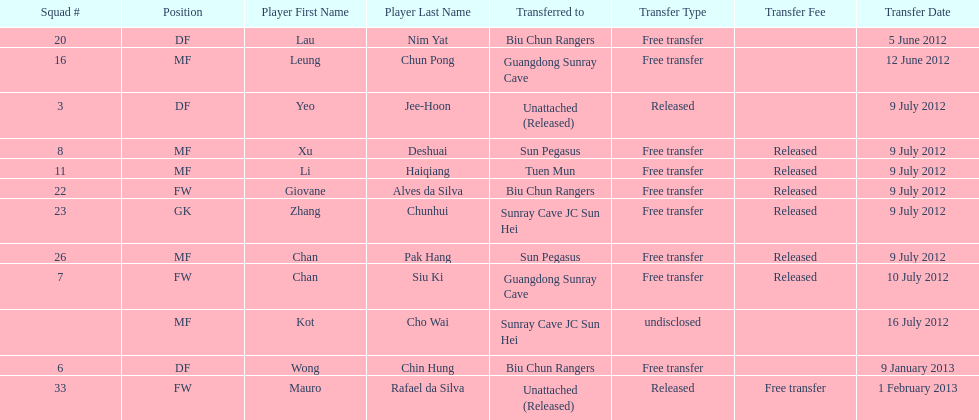What squad # is listed previous to squad # 7? 26. 